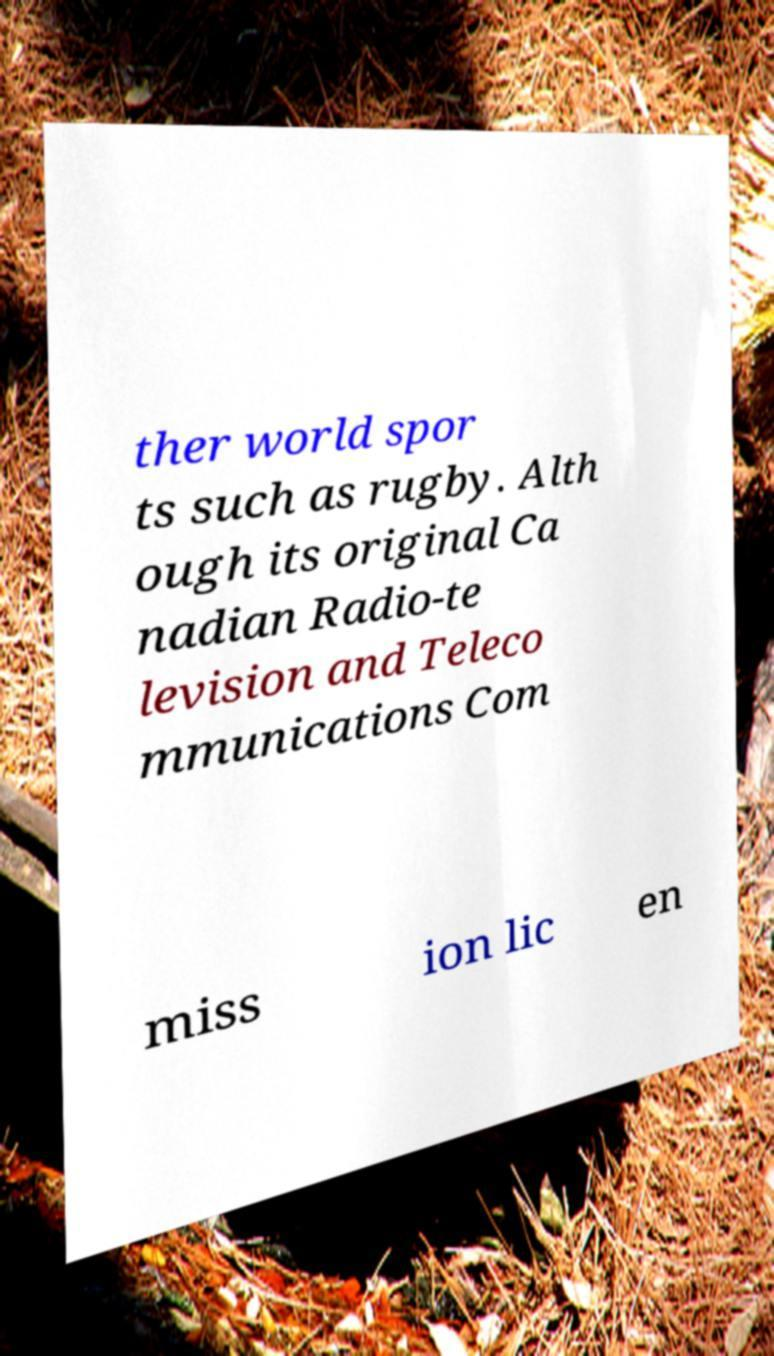Please read and relay the text visible in this image. What does it say? ther world spor ts such as rugby. Alth ough its original Ca nadian Radio-te levision and Teleco mmunications Com miss ion lic en 